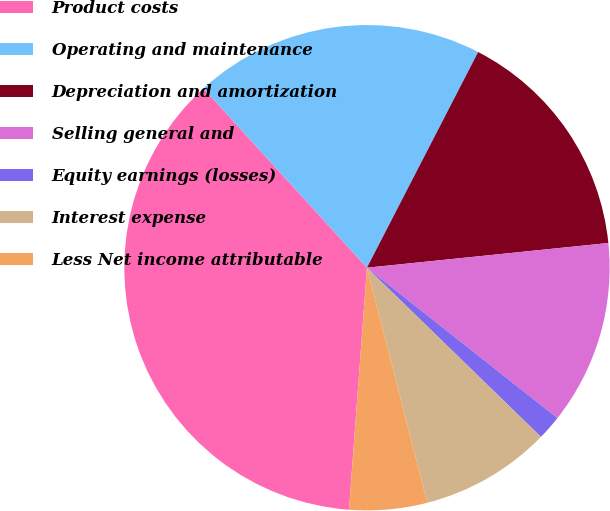<chart> <loc_0><loc_0><loc_500><loc_500><pie_chart><fcel>Product costs<fcel>Operating and maintenance<fcel>Depreciation and amortization<fcel>Selling general and<fcel>Equity earnings (losses)<fcel>Interest expense<fcel>Less Net income attributable<nl><fcel>37.05%<fcel>19.34%<fcel>15.8%<fcel>12.26%<fcel>1.64%<fcel>8.72%<fcel>5.18%<nl></chart> 